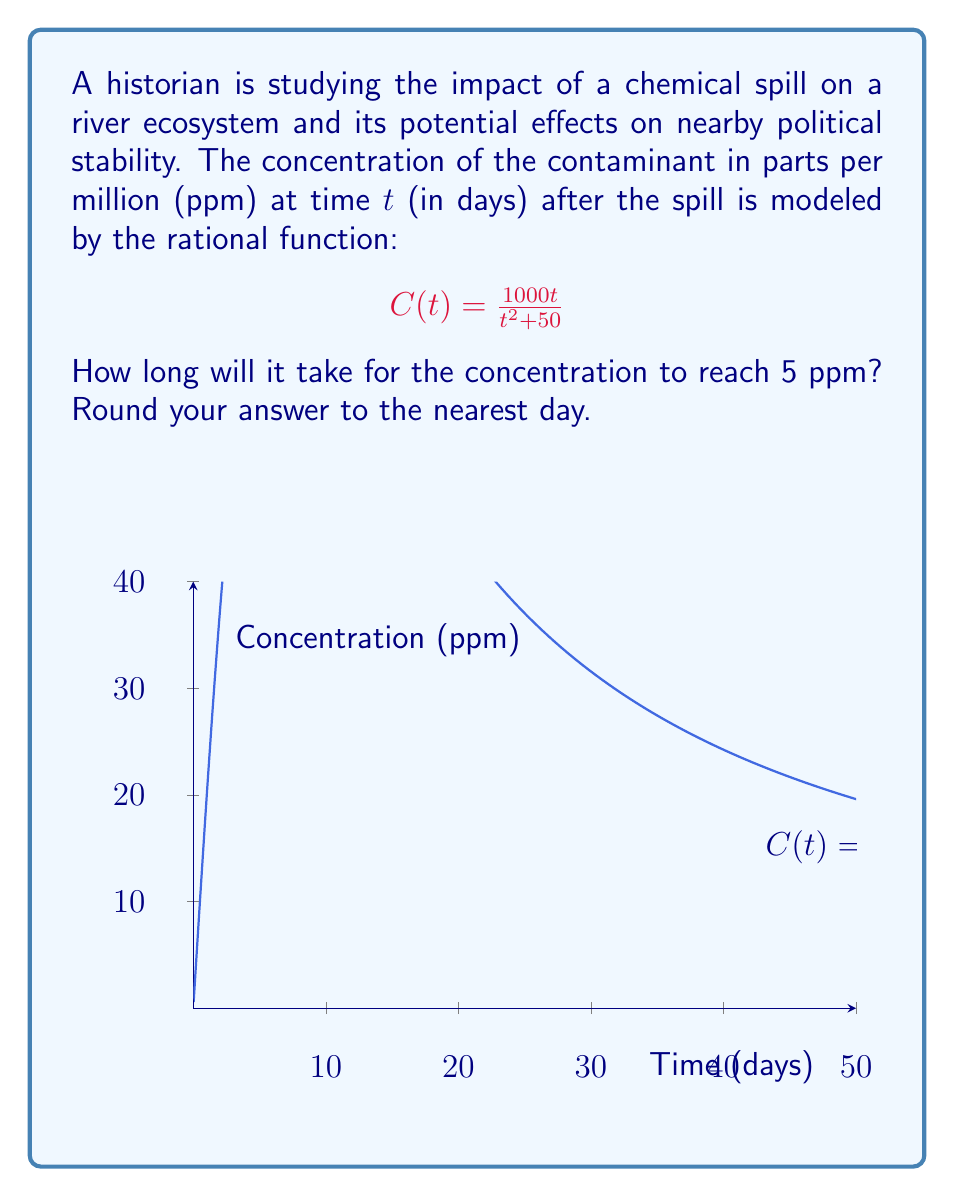Could you help me with this problem? To solve this problem, we need to follow these steps:

1) We want to find $t$ when $C(t) = 5$. So, we set up the equation:

   $$5 = \frac{1000t}{t^2 + 50}$$

2) Multiply both sides by $(t^2 + 50)$:

   $$5(t^2 + 50) = 1000t$$

3) Expand the left side:

   $$5t^2 + 250 = 1000t$$

4) Rearrange to standard form:

   $$5t^2 - 1000t + 250 = 0$$

5) This is a quadratic equation. We can solve it using the quadratic formula:
   $$t = \frac{-b \pm \sqrt{b^2 - 4ac}}{2a}$$
   where $a = 5$, $b = -1000$, and $c = 250$

6) Substituting these values:

   $$t = \frac{1000 \pm \sqrt{(-1000)^2 - 4(5)(250)}}{2(5)}$$

7) Simplify under the square root:

   $$t = \frac{1000 \pm \sqrt{1000000 - 5000}}{10} = \frac{1000 \pm \sqrt{995000}}{10}$$

8) Calculate:

   $$t \approx 199.5 \text{ or } 0.5$$

9) Since time cannot be negative and we're looking for when the concentration decreases to 5 ppm, we choose the larger value.

10) Rounding to the nearest day:

    $$t \approx 200 \text{ days}$$
Answer: 200 days 